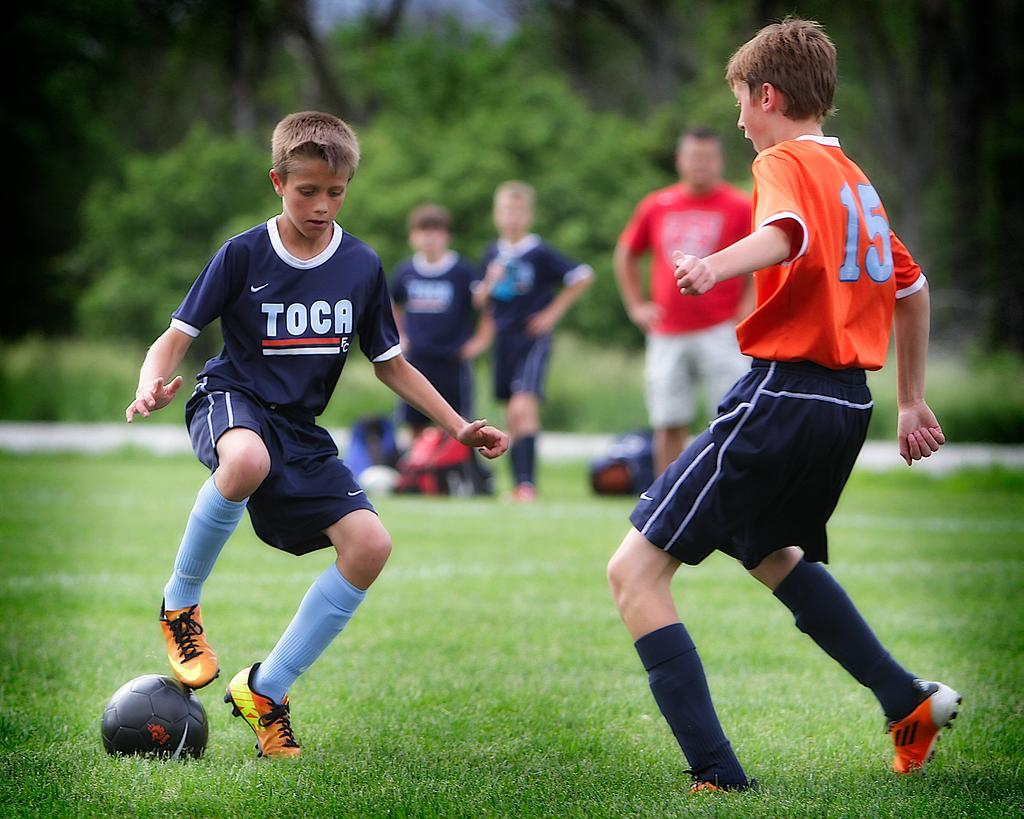How many people are in the image? There are five persons in the image. What are two of the persons doing in the image? Two of the persons are playing with a ball. Where is the ball located in the image? The ball is on grass. What can be seen in the background of the image? There is a tree visible in the background. What type of mist can be seen surrounding the tree in the image? There is no mist present in the image; the tree is visible in the background without any mist. 